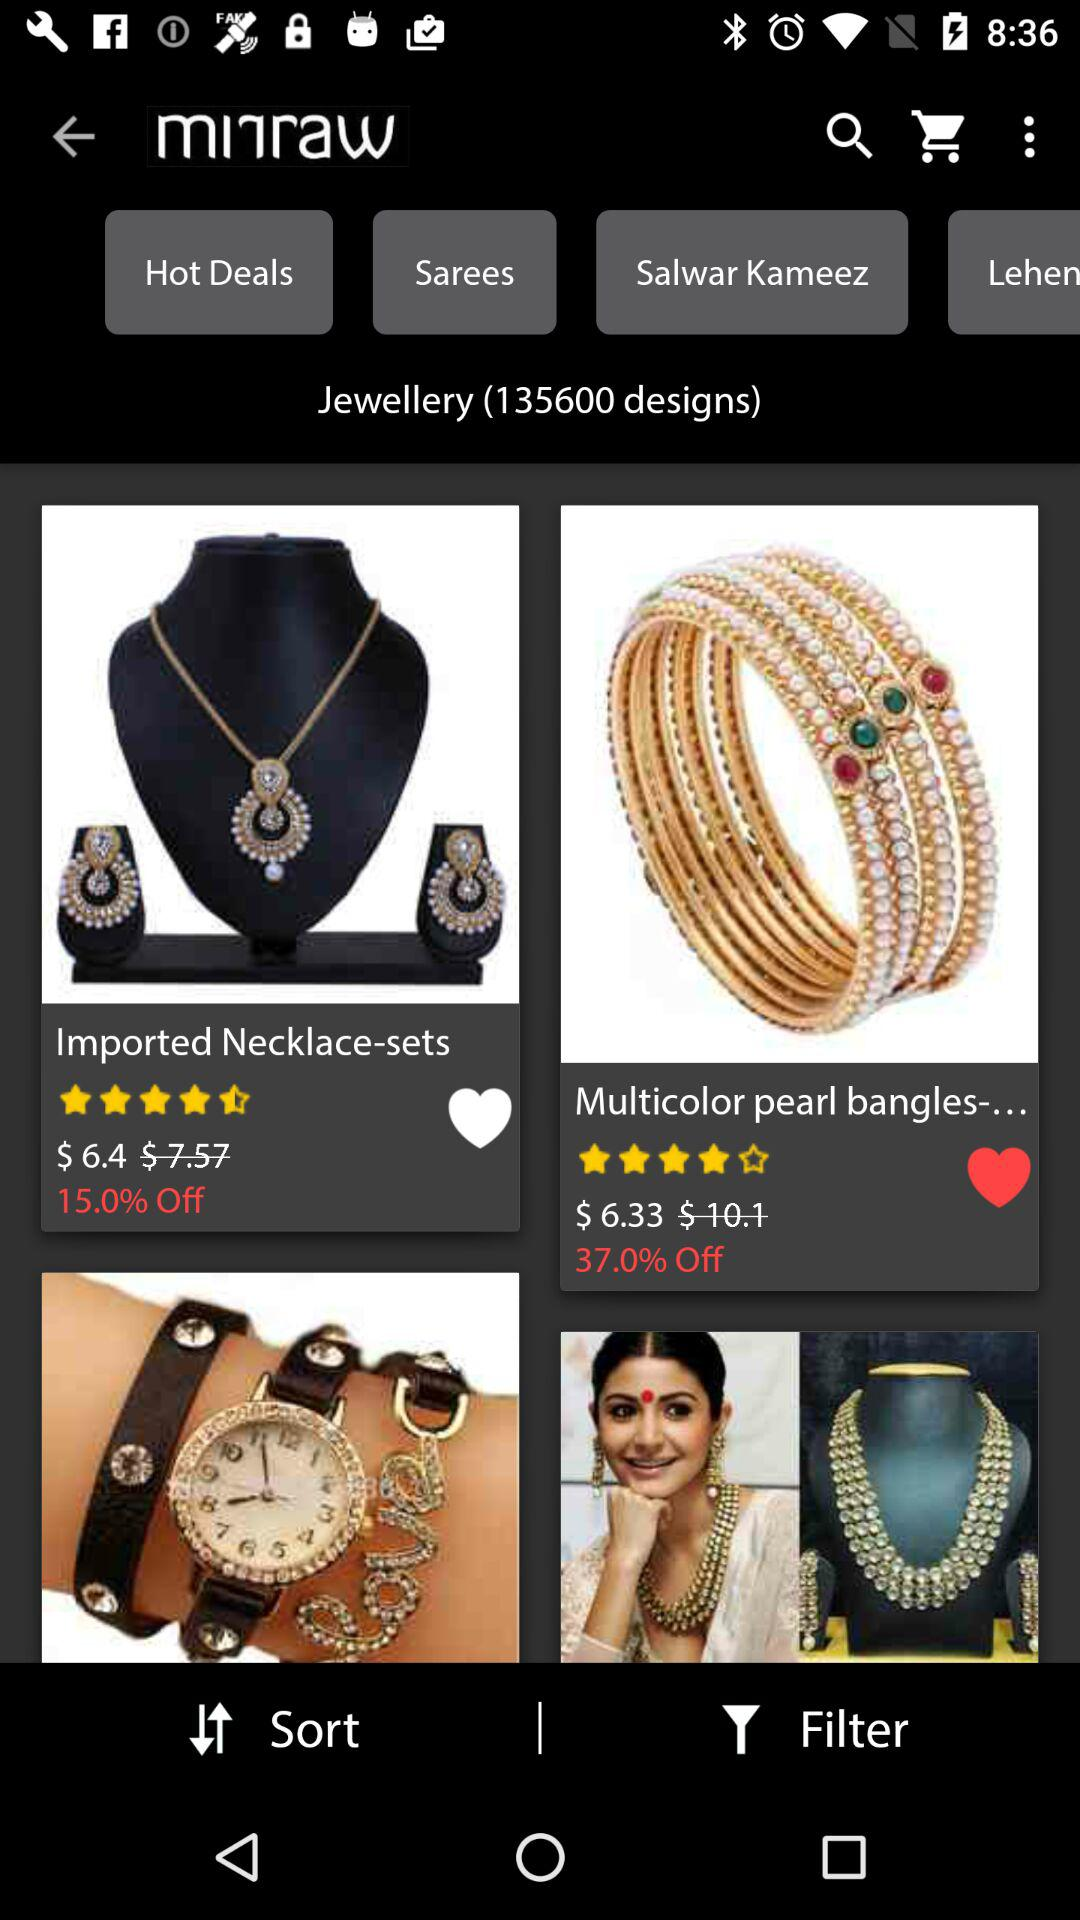What is the discounted price of the necklace sets? The discounted price of the necklace sets is $6.4. 